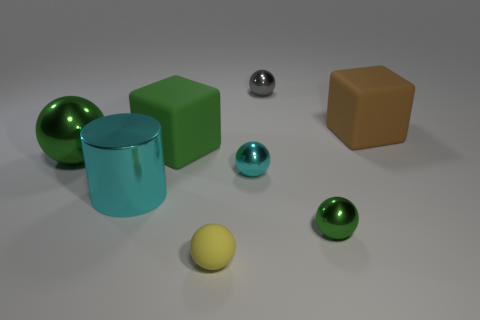There is a small object that is in front of the small green shiny ball that is right of the small yellow object; what is its shape?
Provide a succinct answer. Sphere. Is there a red metallic cylinder of the same size as the gray shiny ball?
Give a very brief answer. No. Is the number of big cylinders less than the number of big green matte spheres?
Make the answer very short. No. The big brown thing behind the cyan metallic object right of the large matte object left of the rubber ball is what shape?
Make the answer very short. Cube. What number of objects are rubber objects that are behind the green rubber cube or green metal balls that are on the left side of the yellow matte sphere?
Provide a short and direct response. 2. There is a brown matte object; are there any large rubber cubes on the left side of it?
Keep it short and to the point. Yes. What number of objects are either big things on the left side of the brown rubber object or big brown rubber things?
Your answer should be very brief. 4. How many blue objects are either large things or metal balls?
Keep it short and to the point. 0. How many other things are there of the same color as the large metallic sphere?
Provide a succinct answer. 2. Is the number of big metal things on the left side of the cylinder less than the number of large cyan things?
Make the answer very short. No. 